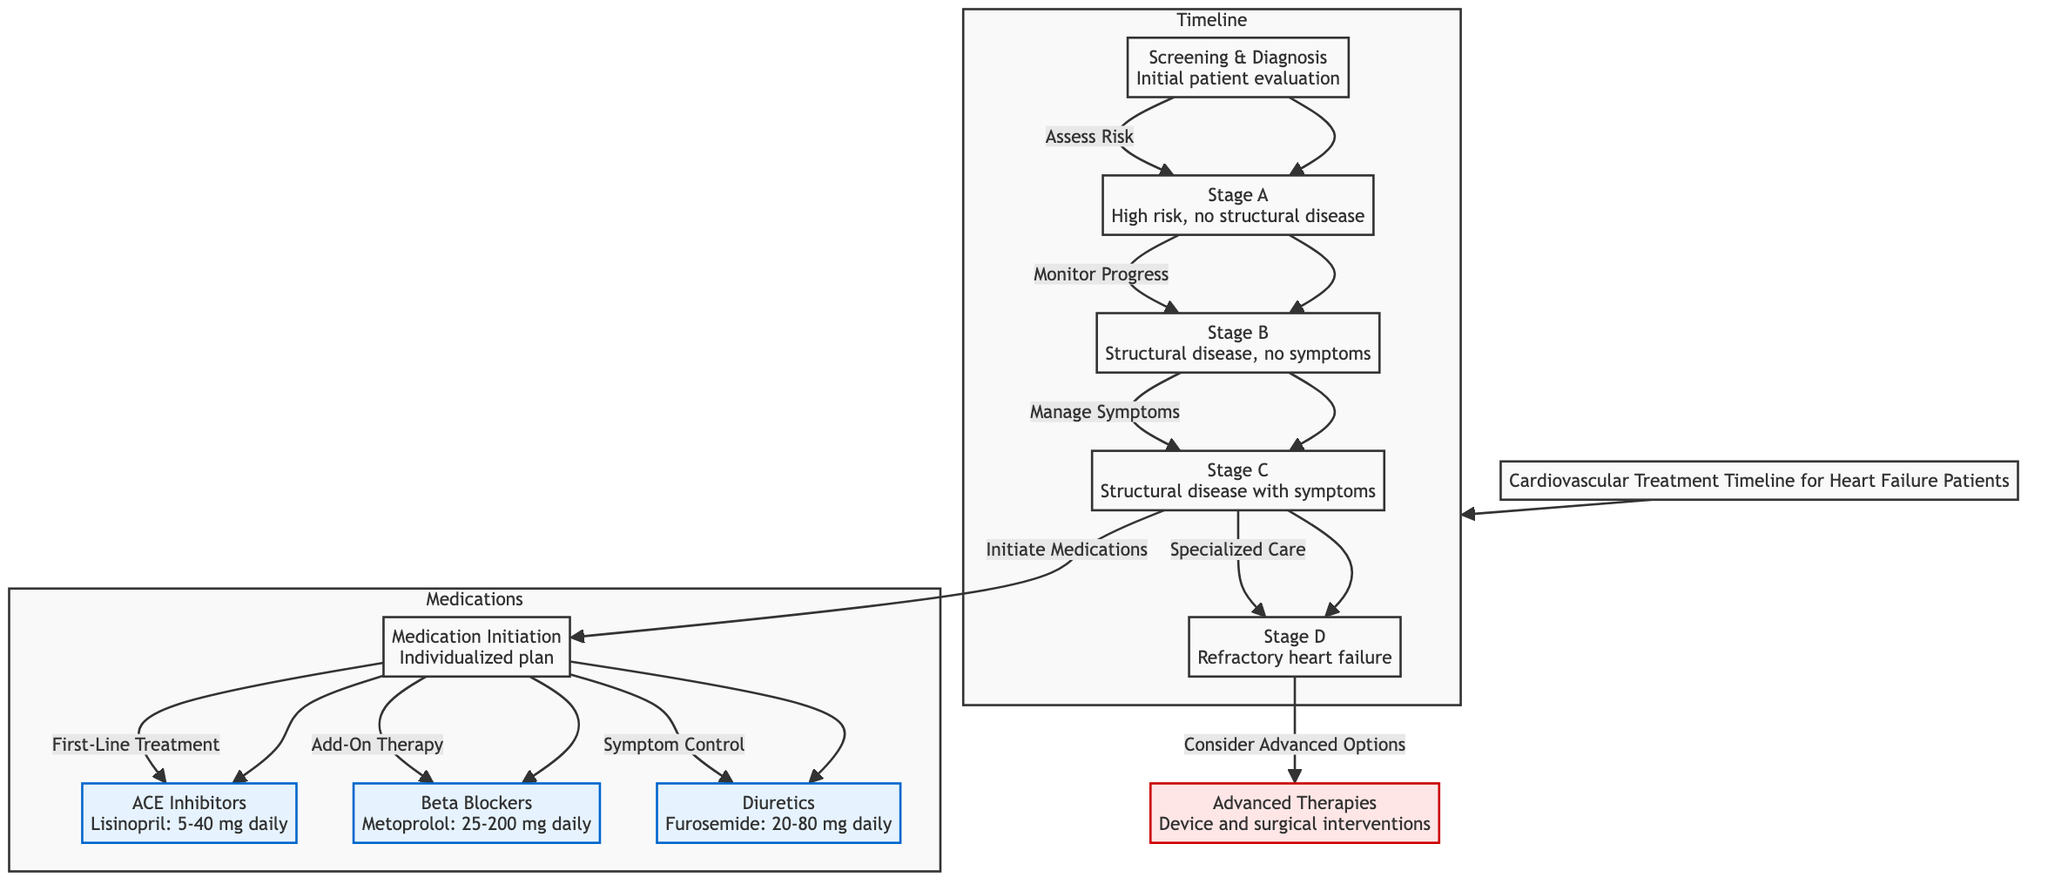What stage is defined as having no structural disease? The diagram indicates that Stage A refers to patients who are at high risk but have no structural disease. This can be found by looking at the node description for Stage A.
Answer: Stage A How many medications are initiated at the Medication Initiation node? The diagram lists three medications that can be initiated from the Medication Initiation node: ACE Inhibitors, Beta Blockers, and Diuretics. Thus, counting these gives a total of three.
Answer: Three What type of therapies are considered for Stage D patients? According to the diagram, patients at Stage D, which involves refractory heart failure, are to consider advanced options; this specifically refers to advanced therapies, which include device and surgical interventions.
Answer: Advanced Therapies Which medication is specifically indicated as first-line treatment? The diagram states that ACE Inhibitors are classified as the first-line treatment under the Medication Initiation node. This specific information can be directly traced from that node's connection to medications.
Answer: ACE Inhibitors What is the dosage range for Metoprolol? The beta-blocker Metoprolol is detailed in the diagram with a dosage range of 25 to 200 mg daily. This specific information is noted next to the Beta Blockers node.
Answer: 25-200 mg daily What follows the Screening & Diagnosis node in the treatment timeline? From the diagram, the Screening & Diagnosis node leads to Stage A, indicating that the process continues from initial evaluation to assessing patient risk and categorizing them into Stage A.
Answer: Stage A What relationship exists between Stage C and medication initiation? The diagram indicates that from Stage C, there is a direct path that leads to the Medication Initiation node, which means that after managing symptoms in Stage C, the treatment plan includes initiating medications.
Answer: Initiation of Medications What is the minimum dosage for Furosemide as shown in the diagram? The diagram specifies that the dosage for the diuretic Furosemide ranges from 20 to 80 mg daily. Therefore, the minimum dosage mentioned is 20 mg daily.
Answer: 20 mg daily 